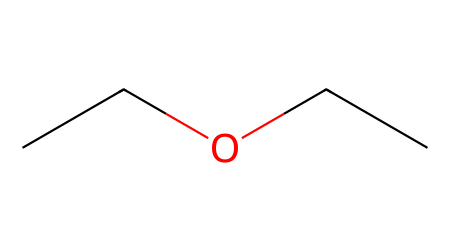What is the name of this chemical? The structure represented by the SMILES CC(O)CC is diethyl ether, which is an ether. The two ethyl (C2H5) groups indicate that it's diethyl.
Answer: diethyl ether How many carbon atoms are in diethyl ether? In the structure, there are two ethyl groups, each containing two carbon atoms, resulting in a total of four carbon atoms.
Answer: four What is the total number of oxygen atoms in diethyl ether? The structure shows one oxygen atom that connects the two ethyl groups. Therefore, there is one oxygen atom in diethyl ether.
Answer: one What type of functional group does diethyl ether contain? The SMILES indicates that there is an ether linkage (-O-) between the two ethyl groups, which classifies it as an ether functional group.
Answer: ether Why is diethyl ether commonly used as a solvent in organic synthesis? Diethyl ether has low polarity and is capable of dissolving a wide range of organic compounds and is highly volatile, making it suitable for organic reactions.
Answer: low polarity What is the molecular formula of diethyl ether? The total count of atoms from the structure (4 carbons, 10 hydrogens, and 1 oxygen) gives the molecular formula C4H10O.
Answer: C4H10O What are the implications of the low boiling point of diethyl ether in laboratory settings? Due to its low boiling point (roughly 34.6°C), diethyl ether evaporates quickly, which can lead to fast drying of samples but also increase risks of flammability and inhalation exposure.
Answer: flammability risks 